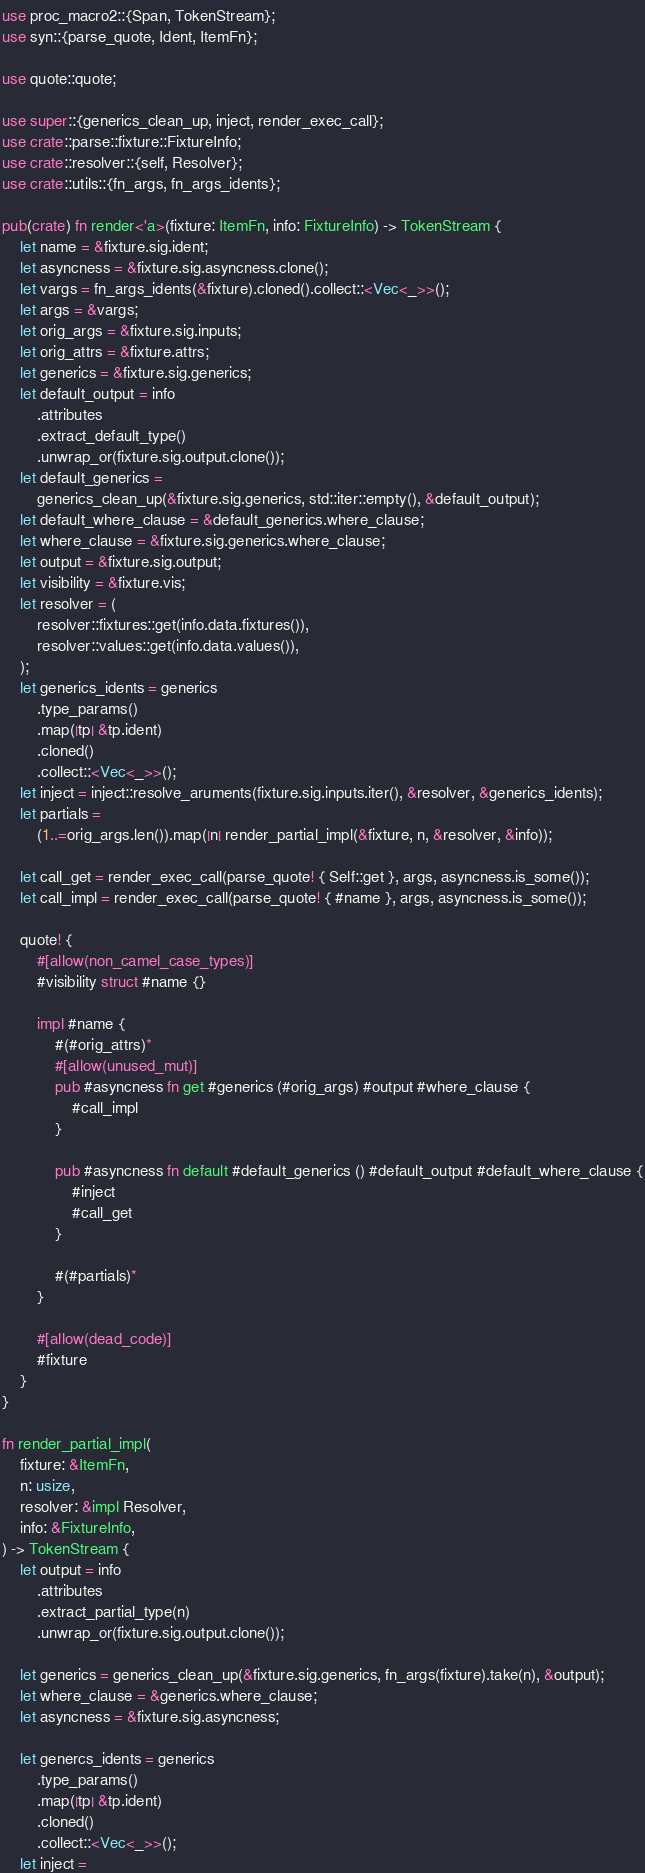Convert code to text. <code><loc_0><loc_0><loc_500><loc_500><_Rust_>use proc_macro2::{Span, TokenStream};
use syn::{parse_quote, Ident, ItemFn};

use quote::quote;

use super::{generics_clean_up, inject, render_exec_call};
use crate::parse::fixture::FixtureInfo;
use crate::resolver::{self, Resolver};
use crate::utils::{fn_args, fn_args_idents};

pub(crate) fn render<'a>(fixture: ItemFn, info: FixtureInfo) -> TokenStream {
    let name = &fixture.sig.ident;
    let asyncness = &fixture.sig.asyncness.clone();
    let vargs = fn_args_idents(&fixture).cloned().collect::<Vec<_>>();
    let args = &vargs;
    let orig_args = &fixture.sig.inputs;
    let orig_attrs = &fixture.attrs;
    let generics = &fixture.sig.generics;
    let default_output = info
        .attributes
        .extract_default_type()
        .unwrap_or(fixture.sig.output.clone());
    let default_generics =
        generics_clean_up(&fixture.sig.generics, std::iter::empty(), &default_output);
    let default_where_clause = &default_generics.where_clause;
    let where_clause = &fixture.sig.generics.where_clause;
    let output = &fixture.sig.output;
    let visibility = &fixture.vis;
    let resolver = (
        resolver::fixtures::get(info.data.fixtures()),
        resolver::values::get(info.data.values()),
    );
    let generics_idents = generics
        .type_params()
        .map(|tp| &tp.ident)
        .cloned()
        .collect::<Vec<_>>();
    let inject = inject::resolve_aruments(fixture.sig.inputs.iter(), &resolver, &generics_idents);
    let partials =
        (1..=orig_args.len()).map(|n| render_partial_impl(&fixture, n, &resolver, &info));

    let call_get = render_exec_call(parse_quote! { Self::get }, args, asyncness.is_some());
    let call_impl = render_exec_call(parse_quote! { #name }, args, asyncness.is_some());

    quote! {
        #[allow(non_camel_case_types)]
        #visibility struct #name {}

        impl #name {
            #(#orig_attrs)*
            #[allow(unused_mut)]
            pub #asyncness fn get #generics (#orig_args) #output #where_clause {
                #call_impl
            }

            pub #asyncness fn default #default_generics () #default_output #default_where_clause {
                #inject
                #call_get
            }

            #(#partials)*
        }

        #[allow(dead_code)]
        #fixture
    }
}

fn render_partial_impl(
    fixture: &ItemFn,
    n: usize,
    resolver: &impl Resolver,
    info: &FixtureInfo,
) -> TokenStream {
    let output = info
        .attributes
        .extract_partial_type(n)
        .unwrap_or(fixture.sig.output.clone());

    let generics = generics_clean_up(&fixture.sig.generics, fn_args(fixture).take(n), &output);
    let where_clause = &generics.where_clause;
    let asyncness = &fixture.sig.asyncness;

    let genercs_idents = generics
        .type_params()
        .map(|tp| &tp.ident)
        .cloned()
        .collect::<Vec<_>>();
    let inject =</code> 